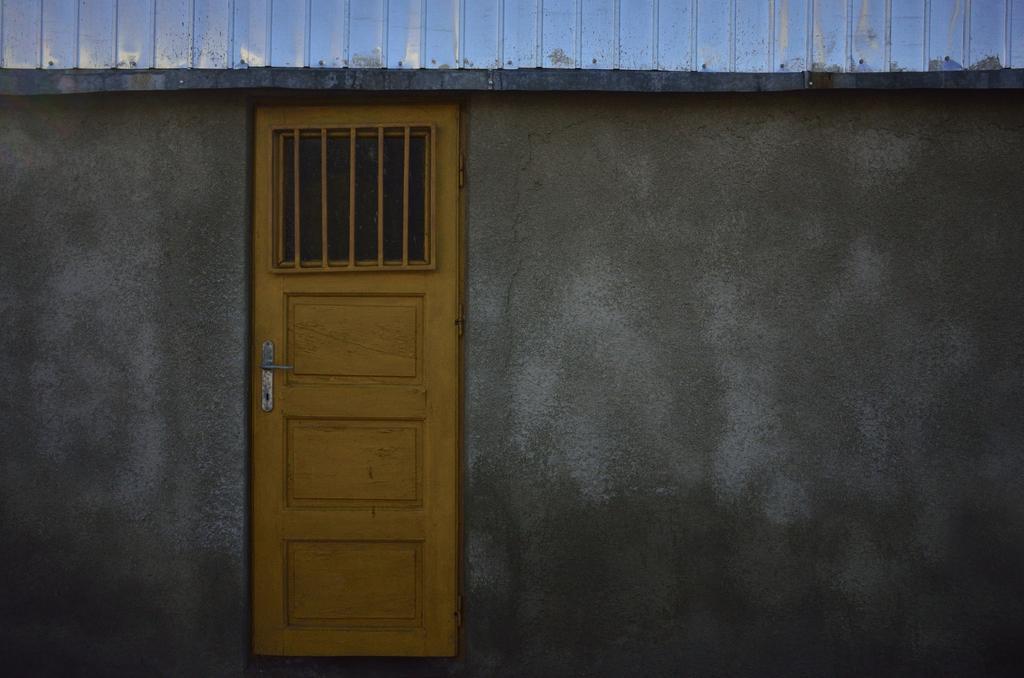How would you summarize this image in a sentence or two? In this image in the center there is one door and a wall, it seems that this is a house. 